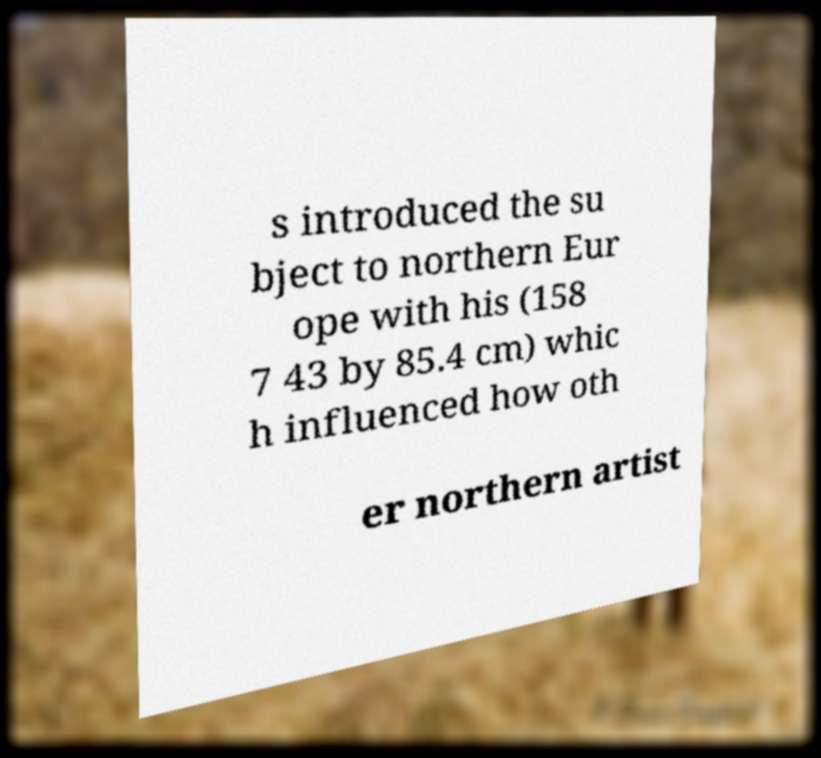Please identify and transcribe the text found in this image. s introduced the su bject to northern Eur ope with his (158 7 43 by 85.4 cm) whic h influenced how oth er northern artist 